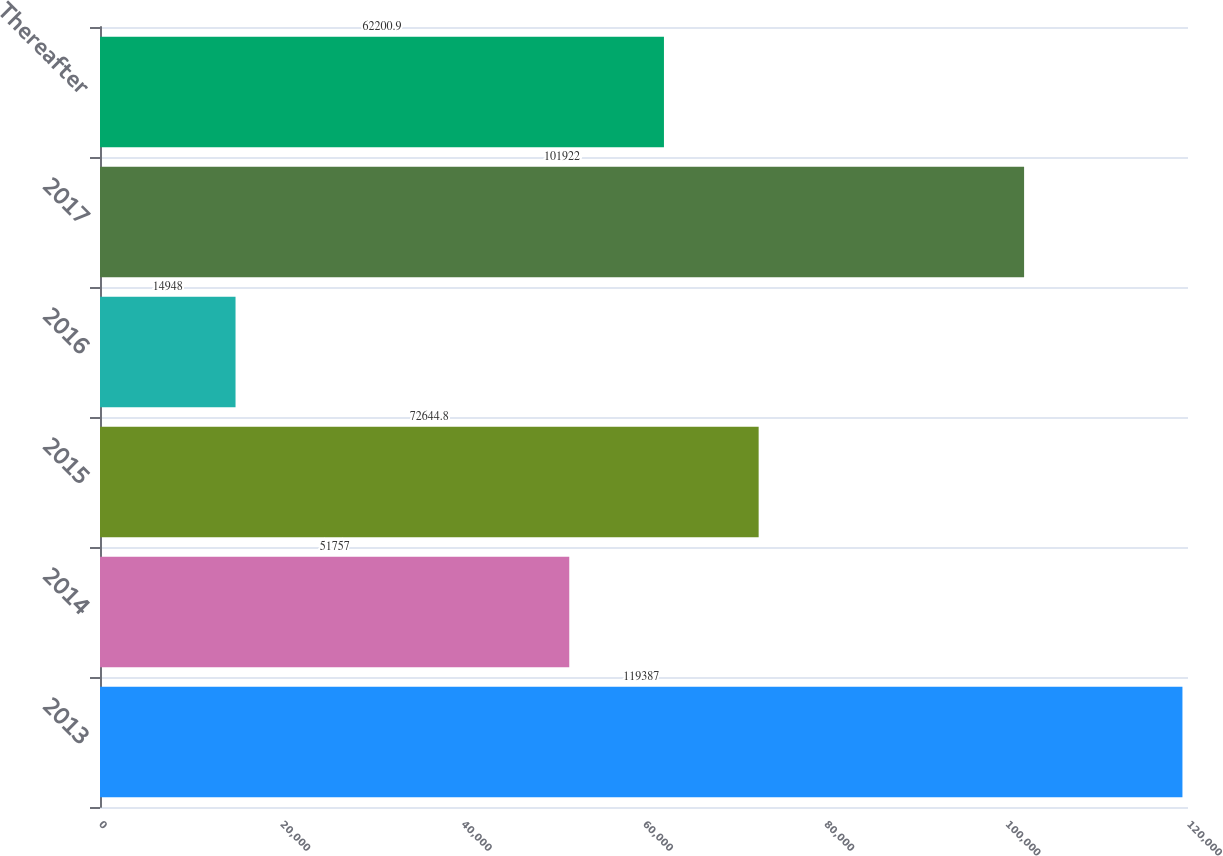<chart> <loc_0><loc_0><loc_500><loc_500><bar_chart><fcel>2013<fcel>2014<fcel>2015<fcel>2016<fcel>2017<fcel>Thereafter<nl><fcel>119387<fcel>51757<fcel>72644.8<fcel>14948<fcel>101922<fcel>62200.9<nl></chart> 